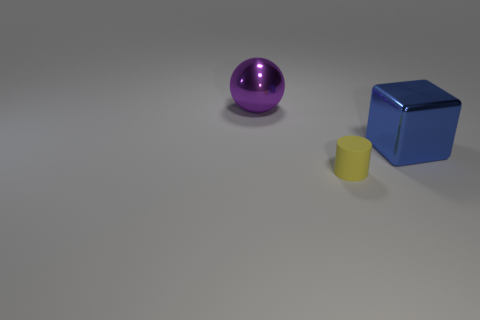Are there any other things that have the same material as the yellow thing?
Provide a short and direct response. No. Do the cube and the rubber cylinder that is in front of the blue block have the same size?
Your answer should be very brief. No. Does the blue cube have the same size as the cylinder?
Provide a succinct answer. No. What is the size of the thing that is on the right side of the big purple metallic sphere and left of the blue metallic cube?
Give a very brief answer. Small. How many matte objects have the same size as the blue metallic block?
Your response must be concise. 0. Is the material of the big object behind the block the same as the small cylinder?
Offer a very short reply. No. Is there a large red rubber object?
Ensure brevity in your answer.  No. There is a thing that is made of the same material as the sphere; what size is it?
Your answer should be very brief. Large. Is there a yellow ball made of the same material as the blue block?
Ensure brevity in your answer.  No. What color is the metallic sphere?
Make the answer very short. Purple. 